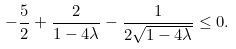<formula> <loc_0><loc_0><loc_500><loc_500>- \frac { 5 } { 2 } + \frac { 2 } { 1 - 4 \lambda } - \frac { 1 } { 2 \sqrt { 1 - 4 \lambda } } \leq 0 .</formula> 